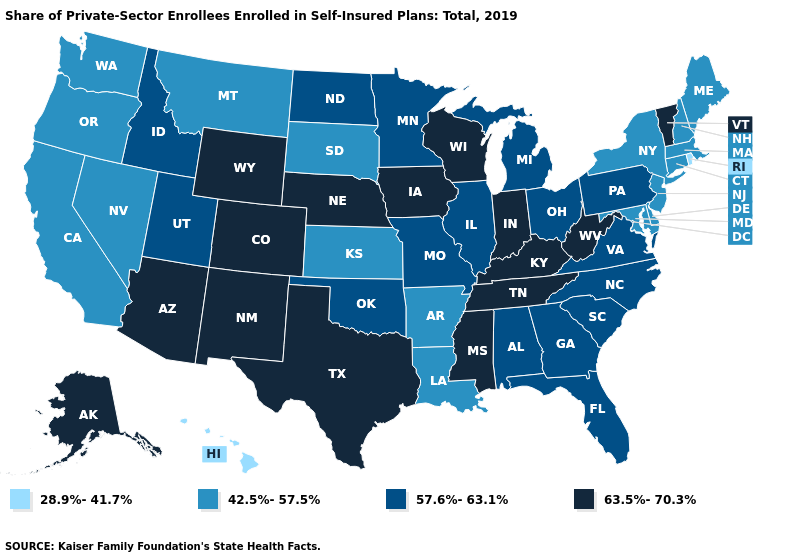What is the value of Vermont?
Concise answer only. 63.5%-70.3%. What is the highest value in the MidWest ?
Write a very short answer. 63.5%-70.3%. Which states have the lowest value in the USA?
Keep it brief. Hawaii, Rhode Island. Among the states that border Ohio , does West Virginia have the lowest value?
Keep it brief. No. What is the lowest value in the West?
Concise answer only. 28.9%-41.7%. Name the states that have a value in the range 57.6%-63.1%?
Be succinct. Alabama, Florida, Georgia, Idaho, Illinois, Michigan, Minnesota, Missouri, North Carolina, North Dakota, Ohio, Oklahoma, Pennsylvania, South Carolina, Utah, Virginia. Does Oklahoma have a lower value than Indiana?
Give a very brief answer. Yes. Which states hav the highest value in the MidWest?
Short answer required. Indiana, Iowa, Nebraska, Wisconsin. Does Ohio have the highest value in the USA?
Give a very brief answer. No. Among the states that border Kansas , which have the lowest value?
Short answer required. Missouri, Oklahoma. Name the states that have a value in the range 28.9%-41.7%?
Quick response, please. Hawaii, Rhode Island. What is the lowest value in the USA?
Short answer required. 28.9%-41.7%. How many symbols are there in the legend?
Concise answer only. 4. Name the states that have a value in the range 28.9%-41.7%?
Give a very brief answer. Hawaii, Rhode Island. Does the map have missing data?
Give a very brief answer. No. 